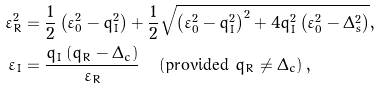<formula> <loc_0><loc_0><loc_500><loc_500>\varepsilon _ { R } ^ { 2 } & = \frac { 1 } { 2 } \left ( \varepsilon _ { 0 } ^ { 2 } - q _ { I } ^ { 2 } \right ) + \frac { 1 } { 2 } \sqrt { \left ( \varepsilon _ { 0 } ^ { 2 } - q _ { I } ^ { 2 } \right ) ^ { 2 } + 4 q _ { I } ^ { 2 } \left ( \varepsilon _ { 0 } ^ { 2 } - \Delta _ { s } ^ { 2 } \right ) } , \\ \varepsilon _ { I } & = \frac { q _ { I } \left ( q _ { R } - \Delta _ { c } \right ) } { \varepsilon _ { R } } \quad \left ( \text {provided $q_{R}\neq\Delta_{c}$} \right ) ,</formula> 